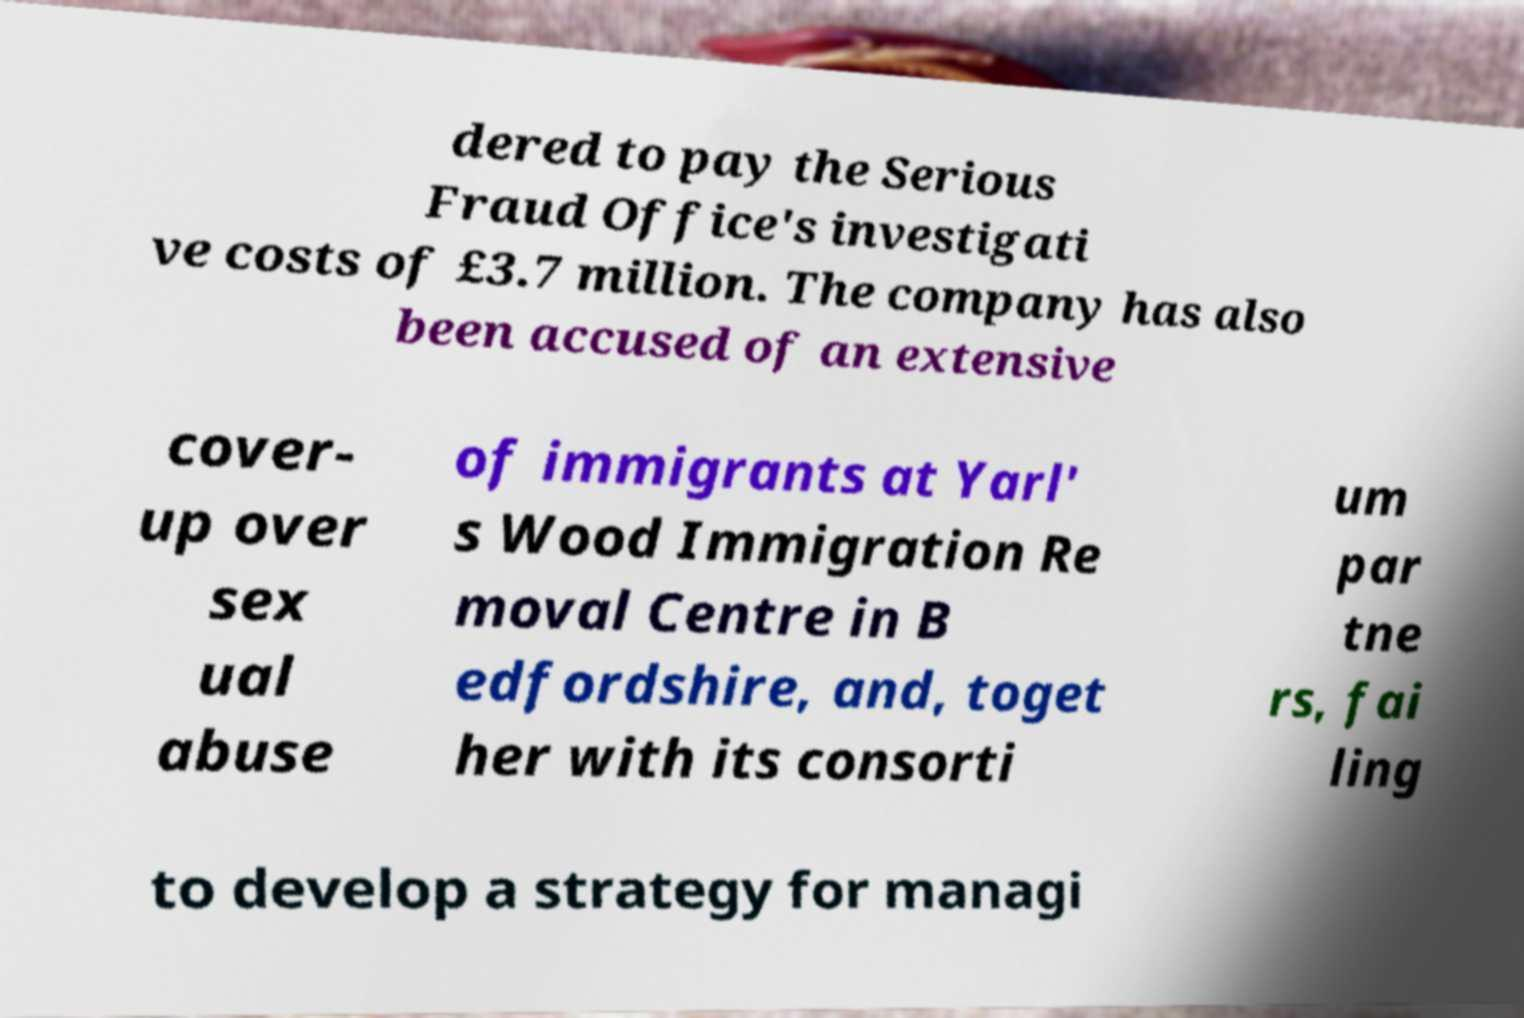Can you accurately transcribe the text from the provided image for me? dered to pay the Serious Fraud Office's investigati ve costs of £3.7 million. The company has also been accused of an extensive cover- up over sex ual abuse of immigrants at Yarl' s Wood Immigration Re moval Centre in B edfordshire, and, toget her with its consorti um par tne rs, fai ling to develop a strategy for managi 